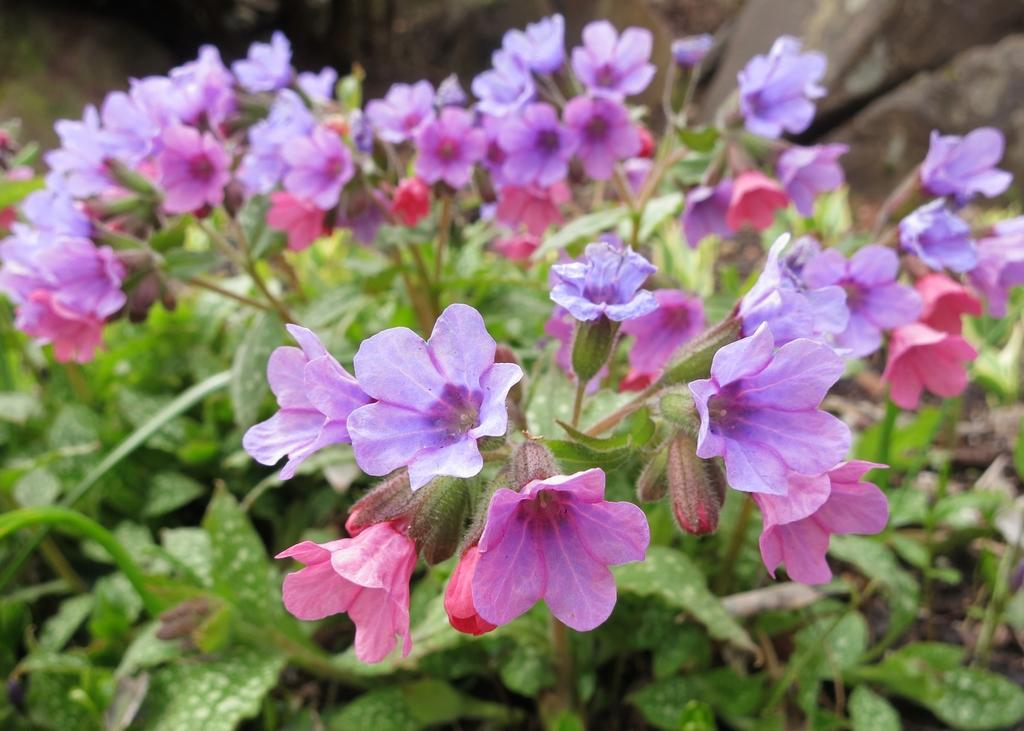What is the main subject of the image? The main subject of the image is a plant. What specific part of the plant can be seen in the image? The image is a zoomed-in picture of the plant. Are there any additional features visible on the plant? Yes, there are flowers on the plant. What type of statement can be heard coming from the fowl in the image? There is no fowl present in the image, as it is a picture of a plant with flowers. 